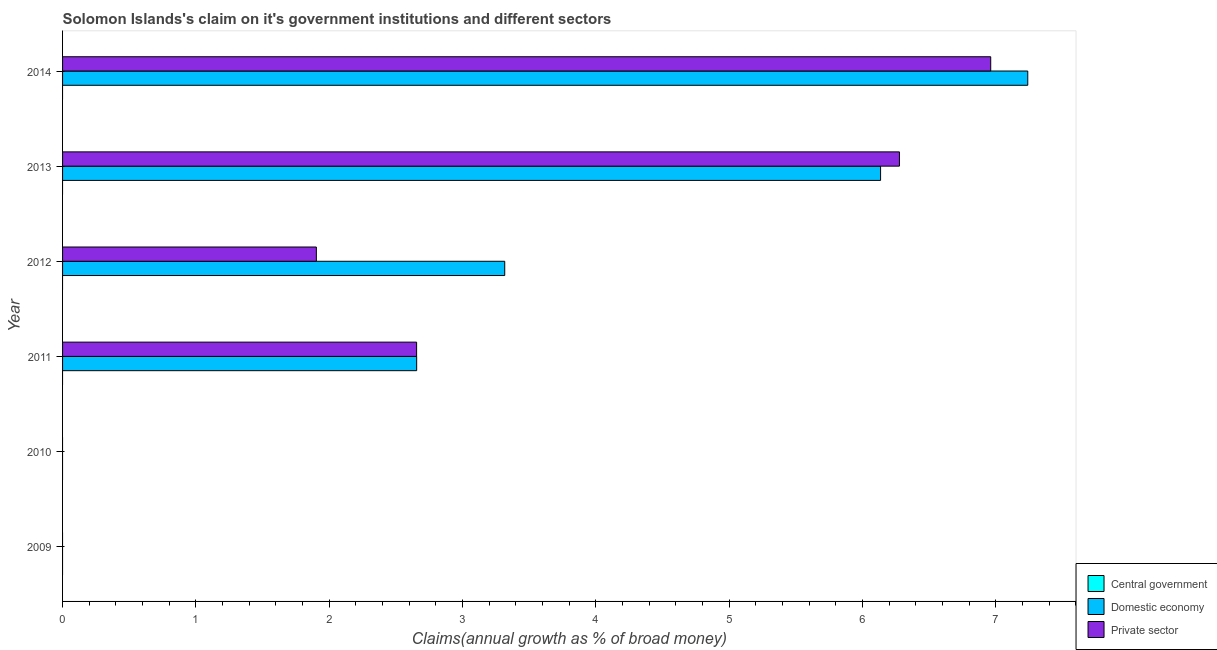What is the label of the 5th group of bars from the top?
Your answer should be compact. 2010. In how many cases, is the number of bars for a given year not equal to the number of legend labels?
Give a very brief answer. 6. What is the percentage of claim on the central government in 2013?
Offer a very short reply. 0. Across all years, what is the maximum percentage of claim on the domestic economy?
Ensure brevity in your answer.  7.24. What is the total percentage of claim on the domestic economy in the graph?
Your response must be concise. 19.35. What is the difference between the percentage of claim on the private sector in 2011 and that in 2013?
Ensure brevity in your answer.  -3.62. What is the difference between the percentage of claim on the central government in 2009 and the percentage of claim on the private sector in 2012?
Offer a very short reply. -1.9. What is the average percentage of claim on the domestic economy per year?
Make the answer very short. 3.23. In the year 2011, what is the difference between the percentage of claim on the domestic economy and percentage of claim on the private sector?
Your answer should be very brief. 0. In how many years, is the percentage of claim on the private sector greater than 6 %?
Your answer should be compact. 2. Is the difference between the percentage of claim on the private sector in 2013 and 2014 greater than the difference between the percentage of claim on the domestic economy in 2013 and 2014?
Keep it short and to the point. Yes. What is the difference between the highest and the second highest percentage of claim on the private sector?
Your response must be concise. 0.69. What is the difference between the highest and the lowest percentage of claim on the private sector?
Ensure brevity in your answer.  6.96. In how many years, is the percentage of claim on the central government greater than the average percentage of claim on the central government taken over all years?
Provide a short and direct response. 0. Is it the case that in every year, the sum of the percentage of claim on the central government and percentage of claim on the domestic economy is greater than the percentage of claim on the private sector?
Your answer should be very brief. No. How many bars are there?
Your answer should be compact. 8. How many years are there in the graph?
Offer a very short reply. 6. What is the difference between two consecutive major ticks on the X-axis?
Ensure brevity in your answer.  1. Does the graph contain grids?
Ensure brevity in your answer.  No. Where does the legend appear in the graph?
Ensure brevity in your answer.  Bottom right. How many legend labels are there?
Provide a short and direct response. 3. What is the title of the graph?
Your response must be concise. Solomon Islands's claim on it's government institutions and different sectors. Does "New Zealand" appear as one of the legend labels in the graph?
Provide a short and direct response. No. What is the label or title of the X-axis?
Ensure brevity in your answer.  Claims(annual growth as % of broad money). What is the Claims(annual growth as % of broad money) in Domestic economy in 2010?
Give a very brief answer. 0. What is the Claims(annual growth as % of broad money) of Domestic economy in 2011?
Give a very brief answer. 2.66. What is the Claims(annual growth as % of broad money) of Private sector in 2011?
Ensure brevity in your answer.  2.66. What is the Claims(annual growth as % of broad money) of Central government in 2012?
Make the answer very short. 0. What is the Claims(annual growth as % of broad money) of Domestic economy in 2012?
Make the answer very short. 3.32. What is the Claims(annual growth as % of broad money) of Private sector in 2012?
Keep it short and to the point. 1.9. What is the Claims(annual growth as % of broad money) in Central government in 2013?
Offer a terse response. 0. What is the Claims(annual growth as % of broad money) of Domestic economy in 2013?
Your answer should be compact. 6.14. What is the Claims(annual growth as % of broad money) in Private sector in 2013?
Offer a terse response. 6.28. What is the Claims(annual growth as % of broad money) of Central government in 2014?
Give a very brief answer. 0. What is the Claims(annual growth as % of broad money) in Domestic economy in 2014?
Your answer should be compact. 7.24. What is the Claims(annual growth as % of broad money) of Private sector in 2014?
Offer a very short reply. 6.96. Across all years, what is the maximum Claims(annual growth as % of broad money) in Domestic economy?
Ensure brevity in your answer.  7.24. Across all years, what is the maximum Claims(annual growth as % of broad money) of Private sector?
Give a very brief answer. 6.96. Across all years, what is the minimum Claims(annual growth as % of broad money) of Domestic economy?
Give a very brief answer. 0. What is the total Claims(annual growth as % of broad money) of Central government in the graph?
Provide a succinct answer. 0. What is the total Claims(annual growth as % of broad money) in Domestic economy in the graph?
Offer a terse response. 19.35. What is the total Claims(annual growth as % of broad money) in Private sector in the graph?
Provide a short and direct response. 17.8. What is the difference between the Claims(annual growth as % of broad money) in Domestic economy in 2011 and that in 2012?
Your answer should be very brief. -0.66. What is the difference between the Claims(annual growth as % of broad money) of Private sector in 2011 and that in 2012?
Give a very brief answer. 0.75. What is the difference between the Claims(annual growth as % of broad money) of Domestic economy in 2011 and that in 2013?
Provide a succinct answer. -3.48. What is the difference between the Claims(annual growth as % of broad money) of Private sector in 2011 and that in 2013?
Offer a terse response. -3.62. What is the difference between the Claims(annual growth as % of broad money) of Domestic economy in 2011 and that in 2014?
Ensure brevity in your answer.  -4.58. What is the difference between the Claims(annual growth as % of broad money) in Private sector in 2011 and that in 2014?
Ensure brevity in your answer.  -4.31. What is the difference between the Claims(annual growth as % of broad money) of Domestic economy in 2012 and that in 2013?
Give a very brief answer. -2.82. What is the difference between the Claims(annual growth as % of broad money) of Private sector in 2012 and that in 2013?
Make the answer very short. -4.37. What is the difference between the Claims(annual growth as % of broad money) in Domestic economy in 2012 and that in 2014?
Ensure brevity in your answer.  -3.92. What is the difference between the Claims(annual growth as % of broad money) in Private sector in 2012 and that in 2014?
Your response must be concise. -5.06. What is the difference between the Claims(annual growth as % of broad money) of Domestic economy in 2013 and that in 2014?
Your answer should be compact. -1.1. What is the difference between the Claims(annual growth as % of broad money) in Private sector in 2013 and that in 2014?
Provide a short and direct response. -0.68. What is the difference between the Claims(annual growth as % of broad money) of Domestic economy in 2011 and the Claims(annual growth as % of broad money) of Private sector in 2012?
Offer a very short reply. 0.75. What is the difference between the Claims(annual growth as % of broad money) of Domestic economy in 2011 and the Claims(annual growth as % of broad money) of Private sector in 2013?
Provide a short and direct response. -3.62. What is the difference between the Claims(annual growth as % of broad money) of Domestic economy in 2011 and the Claims(annual growth as % of broad money) of Private sector in 2014?
Keep it short and to the point. -4.31. What is the difference between the Claims(annual growth as % of broad money) of Domestic economy in 2012 and the Claims(annual growth as % of broad money) of Private sector in 2013?
Provide a short and direct response. -2.96. What is the difference between the Claims(annual growth as % of broad money) of Domestic economy in 2012 and the Claims(annual growth as % of broad money) of Private sector in 2014?
Your response must be concise. -3.65. What is the difference between the Claims(annual growth as % of broad money) in Domestic economy in 2013 and the Claims(annual growth as % of broad money) in Private sector in 2014?
Keep it short and to the point. -0.83. What is the average Claims(annual growth as % of broad money) in Domestic economy per year?
Offer a very short reply. 3.22. What is the average Claims(annual growth as % of broad money) of Private sector per year?
Ensure brevity in your answer.  2.97. In the year 2011, what is the difference between the Claims(annual growth as % of broad money) of Domestic economy and Claims(annual growth as % of broad money) of Private sector?
Provide a short and direct response. 0. In the year 2012, what is the difference between the Claims(annual growth as % of broad money) of Domestic economy and Claims(annual growth as % of broad money) of Private sector?
Give a very brief answer. 1.41. In the year 2013, what is the difference between the Claims(annual growth as % of broad money) of Domestic economy and Claims(annual growth as % of broad money) of Private sector?
Provide a short and direct response. -0.14. In the year 2014, what is the difference between the Claims(annual growth as % of broad money) of Domestic economy and Claims(annual growth as % of broad money) of Private sector?
Provide a succinct answer. 0.28. What is the ratio of the Claims(annual growth as % of broad money) in Domestic economy in 2011 to that in 2012?
Give a very brief answer. 0.8. What is the ratio of the Claims(annual growth as % of broad money) in Private sector in 2011 to that in 2012?
Provide a succinct answer. 1.4. What is the ratio of the Claims(annual growth as % of broad money) in Domestic economy in 2011 to that in 2013?
Make the answer very short. 0.43. What is the ratio of the Claims(annual growth as % of broad money) in Private sector in 2011 to that in 2013?
Offer a very short reply. 0.42. What is the ratio of the Claims(annual growth as % of broad money) in Domestic economy in 2011 to that in 2014?
Your response must be concise. 0.37. What is the ratio of the Claims(annual growth as % of broad money) of Private sector in 2011 to that in 2014?
Keep it short and to the point. 0.38. What is the ratio of the Claims(annual growth as % of broad money) of Domestic economy in 2012 to that in 2013?
Your response must be concise. 0.54. What is the ratio of the Claims(annual growth as % of broad money) in Private sector in 2012 to that in 2013?
Your response must be concise. 0.3. What is the ratio of the Claims(annual growth as % of broad money) of Domestic economy in 2012 to that in 2014?
Offer a terse response. 0.46. What is the ratio of the Claims(annual growth as % of broad money) in Private sector in 2012 to that in 2014?
Provide a short and direct response. 0.27. What is the ratio of the Claims(annual growth as % of broad money) of Domestic economy in 2013 to that in 2014?
Offer a very short reply. 0.85. What is the ratio of the Claims(annual growth as % of broad money) in Private sector in 2013 to that in 2014?
Your answer should be very brief. 0.9. What is the difference between the highest and the second highest Claims(annual growth as % of broad money) of Domestic economy?
Keep it short and to the point. 1.1. What is the difference between the highest and the second highest Claims(annual growth as % of broad money) in Private sector?
Your answer should be very brief. 0.68. What is the difference between the highest and the lowest Claims(annual growth as % of broad money) of Domestic economy?
Your response must be concise. 7.24. What is the difference between the highest and the lowest Claims(annual growth as % of broad money) of Private sector?
Provide a short and direct response. 6.96. 